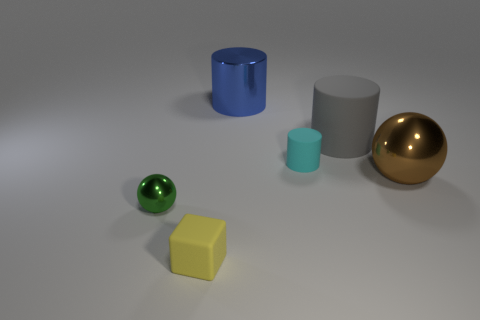Are the yellow object and the tiny green sphere made of the same material?
Ensure brevity in your answer.  No. Is there another large rubber cube that has the same color as the matte cube?
Offer a terse response. No. The gray object that is made of the same material as the cyan object is what size?
Make the answer very short. Large. What shape is the rubber object that is in front of the tiny object on the right side of the object in front of the small sphere?
Your answer should be very brief. Cube. There is a brown metal thing that is the same shape as the green object; what is its size?
Your answer should be compact. Large. There is a object that is behind the small cube and to the left of the metal cylinder; what is its size?
Your response must be concise. Small. The metal cylinder has what color?
Your answer should be compact. Blue. There is a rubber cylinder that is behind the cyan thing; what size is it?
Your answer should be compact. Large. How many metal balls are left of the ball to the right of the thing that is in front of the small green object?
Offer a terse response. 1. What is the color of the small block in front of the shiny thing that is on the left side of the small yellow matte cube?
Your answer should be very brief. Yellow. 